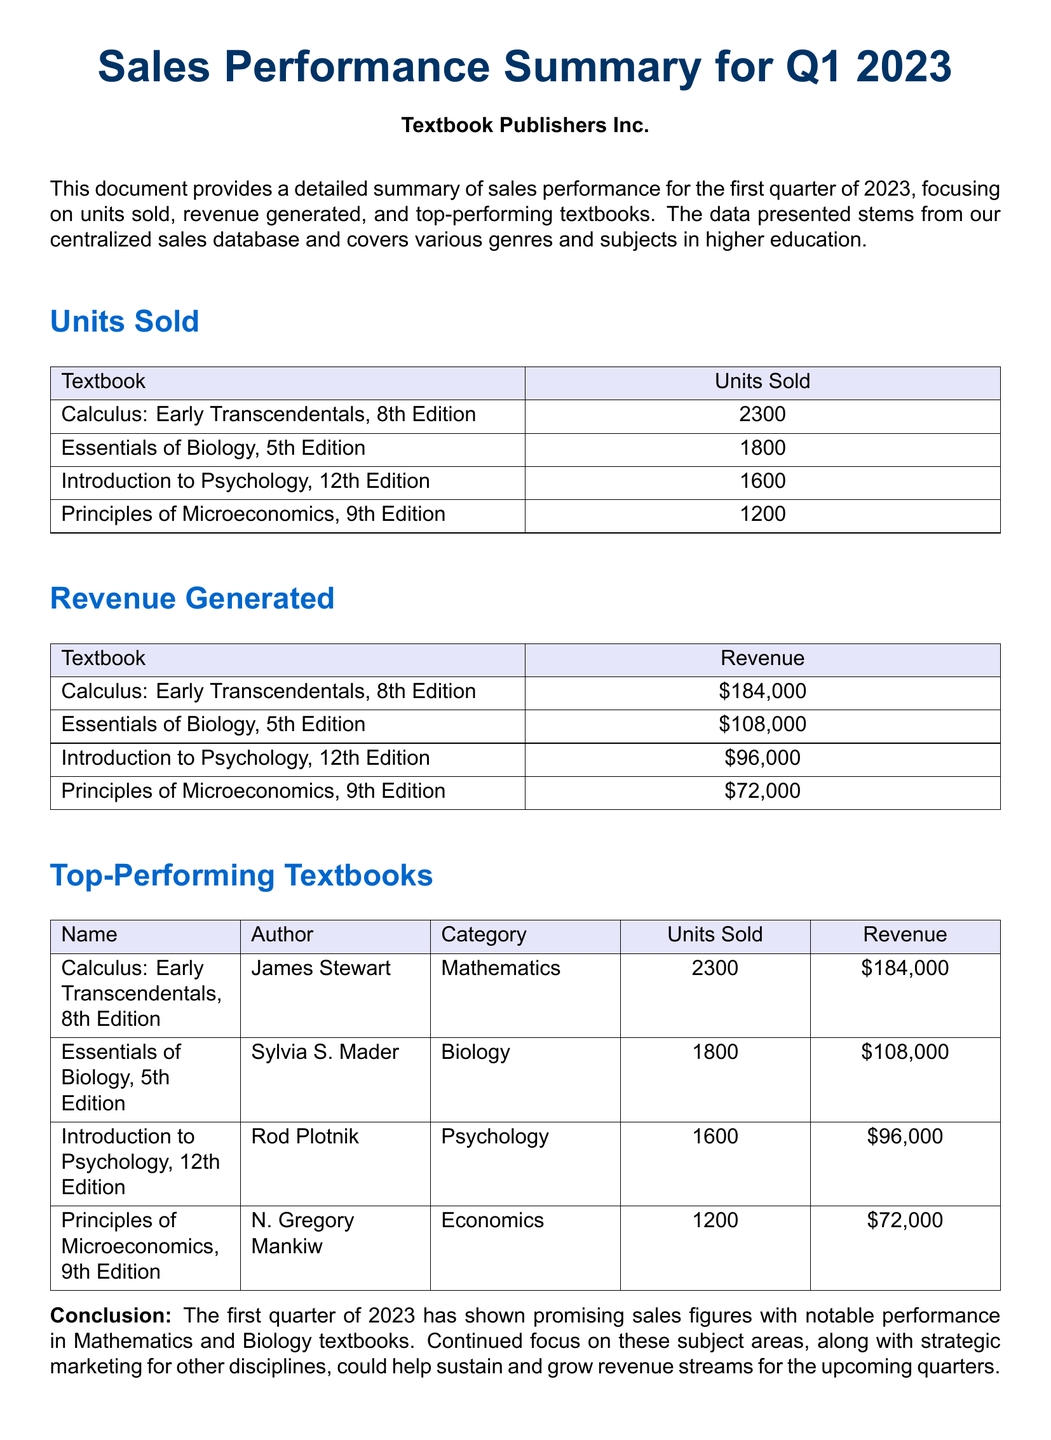What are the top-selling units? The document lists the units sold for each textbook, with the highest being Calculus: Early Transcendentals at 2300 units.
Answer: 2300 What was the revenue for the Essentials of Biology? The document specifies the revenue generated from the Essentials of Biology, 5th Edition as $108,000.
Answer: $108,000 Who is the author of the Introduction to Psychology? The document includes the author's name for the Introduction to Psychology, 12th Edition, which is Rod Plotnik.
Answer: Rod Plotnik How many units were sold in total? The total number of units sold is the sum of all listed units: 2300 + 1800 + 1600 + 1200.
Answer: 6900 Which category had the highest revenue? By examining the revenue generated, Mathematics (Calculus: Early Transcendentals) shows the highest revenue of $184,000.
Answer: Mathematics What is the main focus of the document? The document summarizes sales performance, particularly looking at units sold, revenue, and top-performing textbooks for Q1 2023.
Answer: Sales performance summary Which textbook generated the least revenue? The revenue section indicates that Principles of Microeconomics had the lowest revenue of $72,000.
Answer: $72,000 What was the name of the best-selling textbook? From the units sold information, the best-selling textbook is Calculus: Early Transcendentals, 8th Edition.
Answer: Calculus: Early Transcendentals, 8th Edition What is the purpose of this document? The document aims to provide a summary of sales performance including units sold, revenue generated, and top-performing textbooks for the first quarter.
Answer: Summary of sales performance 